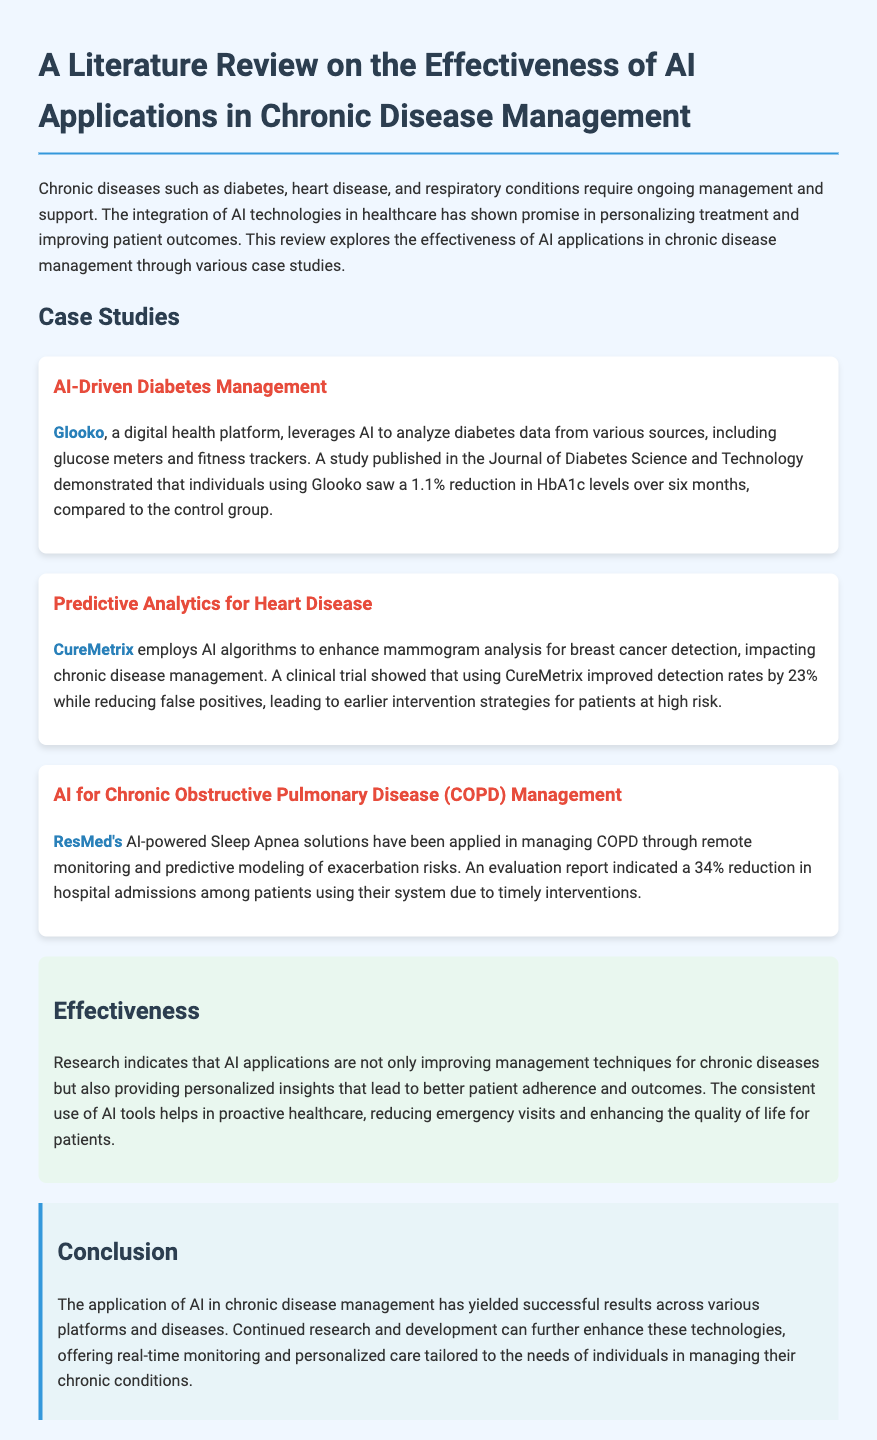what AI platform is used for diabetes management? The document mentions Glooko as the digital health platform used for diabetes management.
Answer: Glooko what percentage reduction in HbA1c levels was observed? According to the case study, individuals using Glooko saw a 1.1% reduction in HbA1c levels.
Answer: 1.1% what improvement in detection rates was achieved using CureMetrix? The clinical trial showed that using CureMetrix improved detection rates by 23%.
Answer: 23% how much did hospital admissions reduce for COPD patients using ResMed's system? The evaluation report indicated a 34% reduction in hospital admissions among patients using ResMed's system.
Answer: 34% what is the primary conclusion about AI in chronic disease management? The conclusion states that the application of AI has yielded successful results across various platforms and diseases.
Answer: Successful results what type of monitoring does ResMed's solution provide for COPD? The document states that ResMed's AI-powered solutions provide remote monitoring for COPD management.
Answer: Remote monitoring what is one benefit of consistent use of AI tools in healthcare? The effectiveness section notes that consistent use of AI tools helps in proactive healthcare.
Answer: Proactive healthcare what chronic diseases are mentioned in the document? The document mentions diabetes, heart disease, and respiratory conditions as examples of chronic diseases.
Answer: Diabetes, heart disease, respiratory conditions 